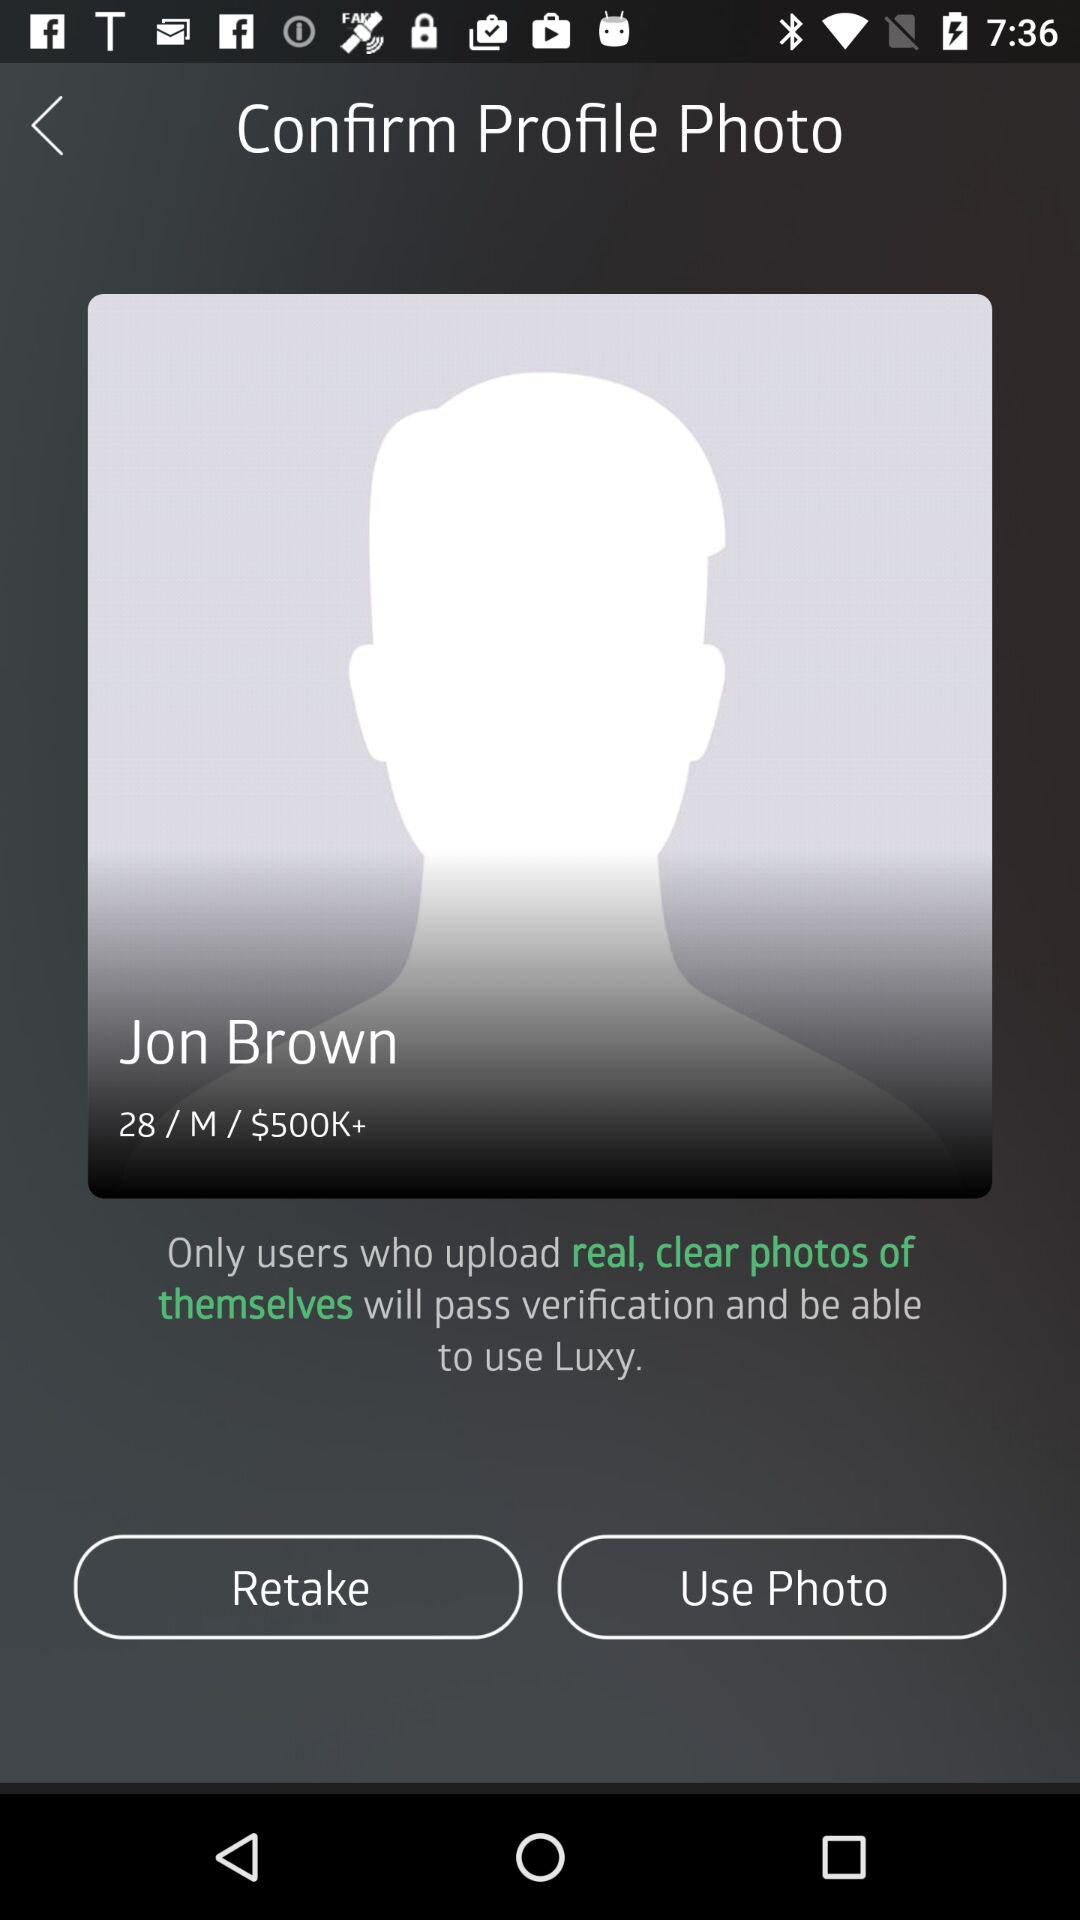Is the photo used?
When the provided information is insufficient, respond with <no answer>. <no answer> 